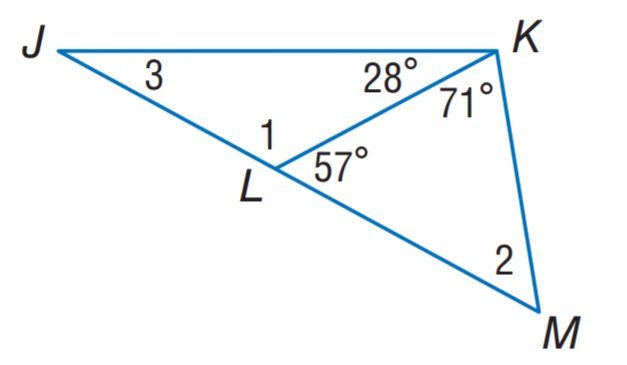Answer the mathemtical geometry problem and directly provide the correct option letter.
Question: Find m \angle 2.
Choices: A: 29 B: 52 C: 57 D: 123 B 